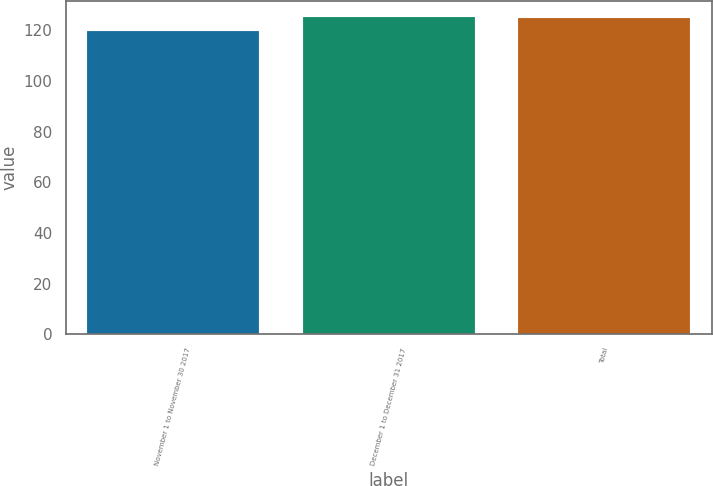Convert chart. <chart><loc_0><loc_0><loc_500><loc_500><bar_chart><fcel>November 1 to November 30 2017<fcel>December 1 to December 31 2017<fcel>Total<nl><fcel>119.63<fcel>125.19<fcel>124.66<nl></chart> 